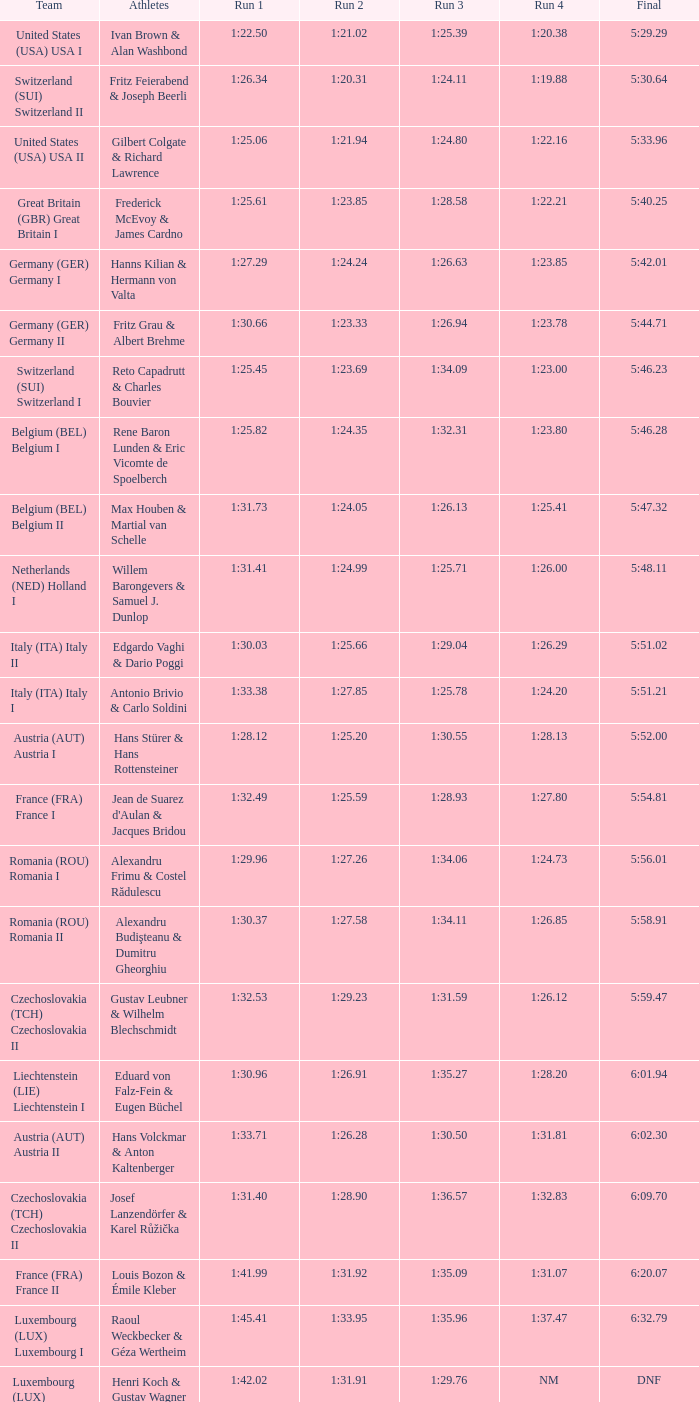63? 1:23.85. 